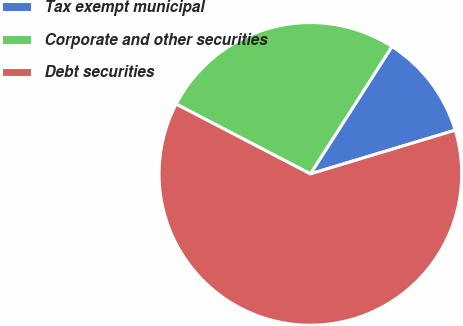Convert chart. <chart><loc_0><loc_0><loc_500><loc_500><pie_chart><fcel>Tax exempt municipal<fcel>Corporate and other securities<fcel>Debt securities<nl><fcel>11.27%<fcel>26.43%<fcel>62.3%<nl></chart> 